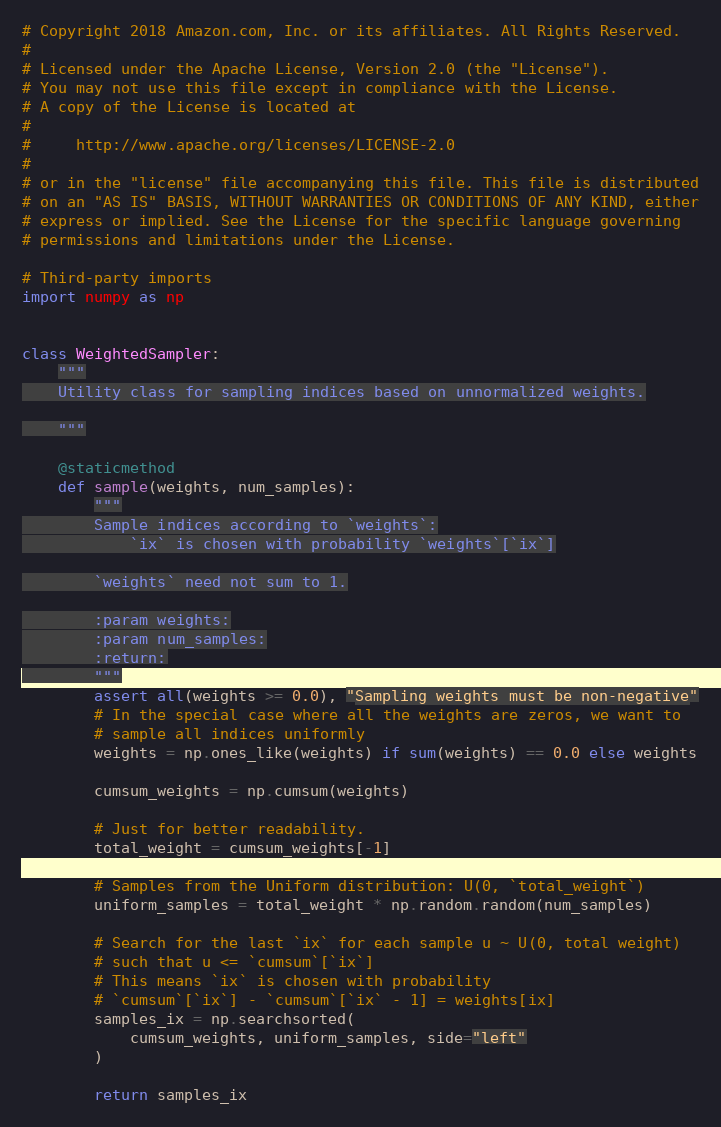<code> <loc_0><loc_0><loc_500><loc_500><_Python_># Copyright 2018 Amazon.com, Inc. or its affiliates. All Rights Reserved.
#
# Licensed under the Apache License, Version 2.0 (the "License").
# You may not use this file except in compliance with the License.
# A copy of the License is located at
#
#     http://www.apache.org/licenses/LICENSE-2.0
#
# or in the "license" file accompanying this file. This file is distributed
# on an "AS IS" BASIS, WITHOUT WARRANTIES OR CONDITIONS OF ANY KIND, either
# express or implied. See the License for the specific language governing
# permissions and limitations under the License.

# Third-party imports
import numpy as np


class WeightedSampler:
    """
    Utility class for sampling indices based on unnormalized weights.

    """

    @staticmethod
    def sample(weights, num_samples):
        """
        Sample indices according to `weights`:
            `ix` is chosen with probability `weights`[`ix`]

        `weights` need not sum to 1.

        :param weights:
        :param num_samples:
        :return:
        """
        assert all(weights >= 0.0), "Sampling weights must be non-negative"
        # In the special case where all the weights are zeros, we want to
        # sample all indices uniformly
        weights = np.ones_like(weights) if sum(weights) == 0.0 else weights

        cumsum_weights = np.cumsum(weights)

        # Just for better readability.
        total_weight = cumsum_weights[-1]

        # Samples from the Uniform distribution: U(0, `total_weight`)
        uniform_samples = total_weight * np.random.random(num_samples)

        # Search for the last `ix` for each sample u ~ U(0, total weight)
        # such that u <= `cumsum`[`ix`]
        # This means `ix` is chosen with probability
        # `cumsum`[`ix`] - `cumsum`[`ix` - 1] = weights[ix]
        samples_ix = np.searchsorted(
            cumsum_weights, uniform_samples, side="left"
        )

        return samples_ix
</code> 